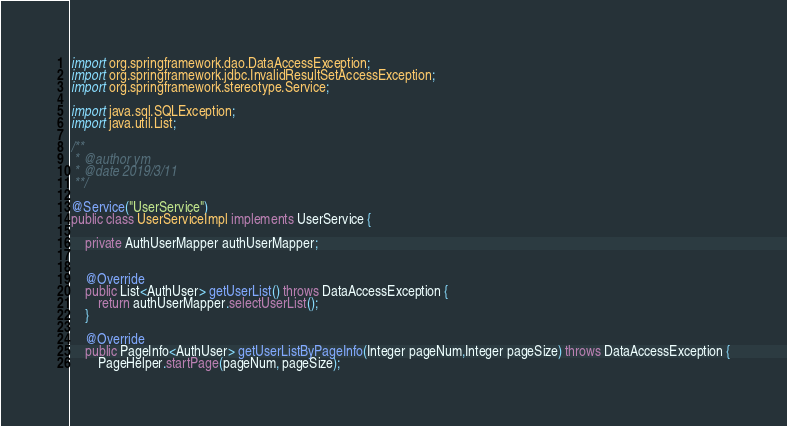Convert code to text. <code><loc_0><loc_0><loc_500><loc_500><_Java_>import org.springframework.dao.DataAccessException;
import org.springframework.jdbc.InvalidResultSetAccessException;
import org.springframework.stereotype.Service;

import java.sql.SQLException;
import java.util.List;

/**
 * @author ym
 * @date 2019/3/11
 **/

@Service("UserService")
public class UserServiceImpl implements UserService {

    private AuthUserMapper authUserMapper;


    @Override
    public List<AuthUser> getUserList() throws DataAccessException {
        return authUserMapper.selectUserList();
    }

    @Override
    public PageInfo<AuthUser> getUserListByPageInfo(Integer pageNum,Integer pageSize) throws DataAccessException {
        PageHelper.startPage(pageNum, pageSize);</code> 